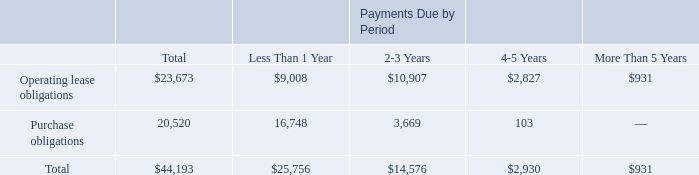Summary Disclosures about Contractual Obligations and Commercial Commitments
Our material capital commitments consist of obligations under facilities and operating leases. Some of these leases have free or escalating rent payment provisions. We recognize rent expense under leases on a straight-line basis. We anticipate that we will experience an increase in our capital expenditures and lease commitments as a result of our anticipated growth in operations, infrastructure, personnel and resources devoted to building our brand name.
The following table summarizes our obligations as of March 31, 2019 (dollars in thousands):
We generally do not enter into binding purchase obligations. The purchase obligations above relate primarily to marketing and IT services. The contractual obligations table above excludes unrecognized tax benefits, plus related interest and penalties totaling $1.1 million because we cannot reasonably estimate in which future periods these amounts will ultimately be settled.
We have certain software royalty commitments associated with the shipment and licensing of certain products. Royalty expense is generally based on a fixed cost per unit shipped or a fixed fee for unlimited units shipped over a designated period. Royalty expense, included in cost of software and products revenues was $12.3 million in fiscal 2019 and $4.5 million million in fiscal 2018.
We offer a 90-day limited product warranty for our software. To date, costs relating to this product warranty have not been material.
What kinds of purchase obligations does the data refer to? Primarily to marketing and it services. How much was the royalty expense in fiscal 2019 and fiscal 2018 respectively?
Answer scale should be: million. $12.3 million, $4.5 million. How long is the product warranty period for the company's software? 90-day. What is the amount of purchase obligations due in the next 3 years?
Answer scale should be: thousand. 16,748+3,669
Answer: 20417. What percentage of operating lease obligations are due in more than 4 years?
Answer scale should be: percent. (931+2,827)/23,673
Answer: 0.16. How much less operating lease obligations than purchase obligations does the company have due in less than 1 year?
Answer scale should be: thousand. 16,748-9,008
Answer: 7740. 